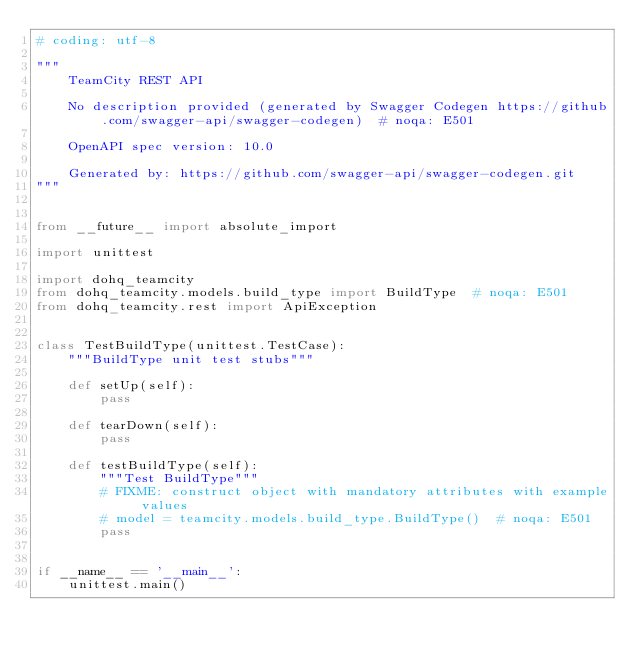Convert code to text. <code><loc_0><loc_0><loc_500><loc_500><_Python_># coding: utf-8

"""
    TeamCity REST API

    No description provided (generated by Swagger Codegen https://github.com/swagger-api/swagger-codegen)  # noqa: E501

    OpenAPI spec version: 10.0
    
    Generated by: https://github.com/swagger-api/swagger-codegen.git
"""


from __future__ import absolute_import

import unittest

import dohq_teamcity
from dohq_teamcity.models.build_type import BuildType  # noqa: E501
from dohq_teamcity.rest import ApiException


class TestBuildType(unittest.TestCase):
    """BuildType unit test stubs"""

    def setUp(self):
        pass

    def tearDown(self):
        pass

    def testBuildType(self):
        """Test BuildType"""
        # FIXME: construct object with mandatory attributes with example values
        # model = teamcity.models.build_type.BuildType()  # noqa: E501
        pass


if __name__ == '__main__':
    unittest.main()
</code> 